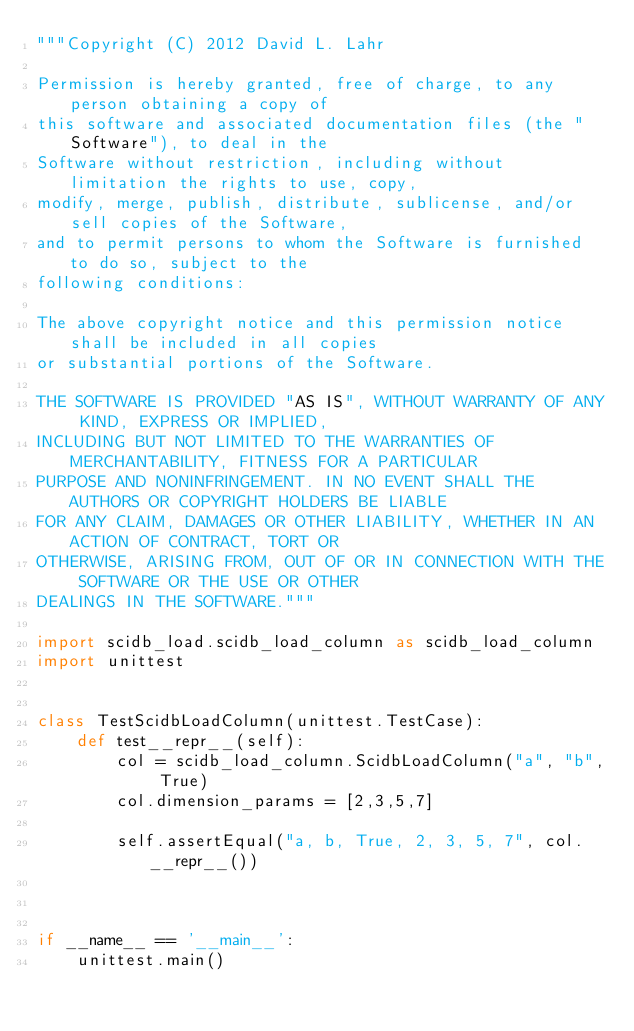<code> <loc_0><loc_0><loc_500><loc_500><_Python_>"""Copyright (C) 2012 David L. Lahr

Permission is hereby granted, free of charge, to any person obtaining a copy of 
this software and associated documentation files (the "Software"), to deal in the 
Software without restriction, including without limitation the rights to use, copy, 
modify, merge, publish, distribute, sublicense, and/or sell copies of the Software,
and to permit persons to whom the Software is furnished to do so, subject to the
following conditions:

The above copyright notice and this permission notice shall be included in all copies
or substantial portions of the Software.

THE SOFTWARE IS PROVIDED "AS IS", WITHOUT WARRANTY OF ANY KIND, EXPRESS OR IMPLIED, 
INCLUDING BUT NOT LIMITED TO THE WARRANTIES OF MERCHANTABILITY, FITNESS FOR A PARTICULAR
PURPOSE AND NONINFRINGEMENT. IN NO EVENT SHALL THE AUTHORS OR COPYRIGHT HOLDERS BE LIABLE
FOR ANY CLAIM, DAMAGES OR OTHER LIABILITY, WHETHER IN AN ACTION OF CONTRACT, TORT OR 
OTHERWISE, ARISING FROM, OUT OF OR IN CONNECTION WITH THE SOFTWARE OR THE USE OR OTHER 
DEALINGS IN THE SOFTWARE."""

import scidb_load.scidb_load_column as scidb_load_column
import unittest


class TestScidbLoadColumn(unittest.TestCase):
    def test__repr__(self):
        col = scidb_load_column.ScidbLoadColumn("a", "b", True)
        col.dimension_params = [2,3,5,7]

        self.assertEqual("a, b, True, 2, 3, 5, 7", col.__repr__())



if __name__ == '__main__':
    unittest.main()

</code> 